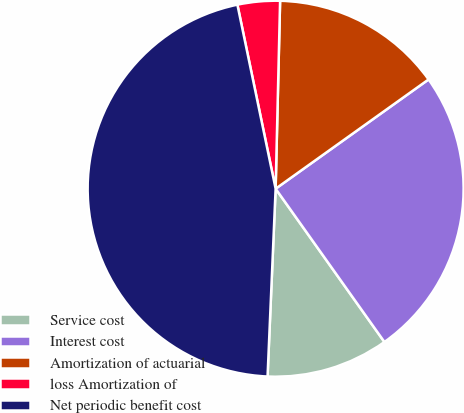<chart> <loc_0><loc_0><loc_500><loc_500><pie_chart><fcel>Service cost<fcel>Interest cost<fcel>Amortization of actuarial<fcel>loss Amortization of<fcel>Net periodic benefit cost<nl><fcel>10.51%<fcel>25.05%<fcel>14.75%<fcel>3.64%<fcel>46.06%<nl></chart> 